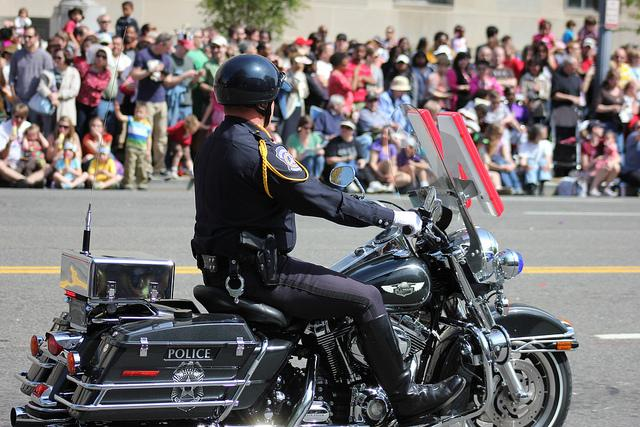What are the people on the street side focused on?

Choices:
A) snacks
B) arrest
C) sirens
D) parade parade 